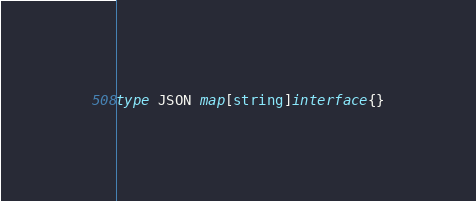<code> <loc_0><loc_0><loc_500><loc_500><_Go_>type JSON map[string]interface{}
</code> 